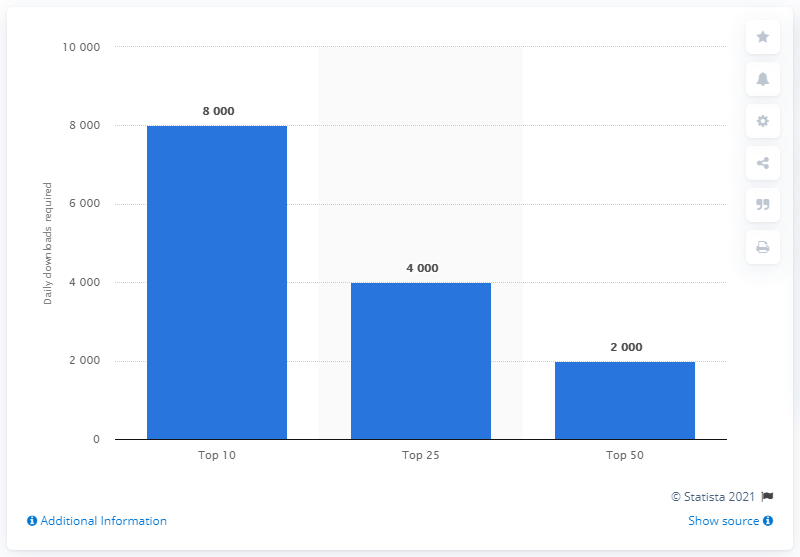Identify some key points in this picture. The ranking of the most downloaded apps in Australia's Apple app store is as follows: the top 10 apps account for the majority of downloads. 